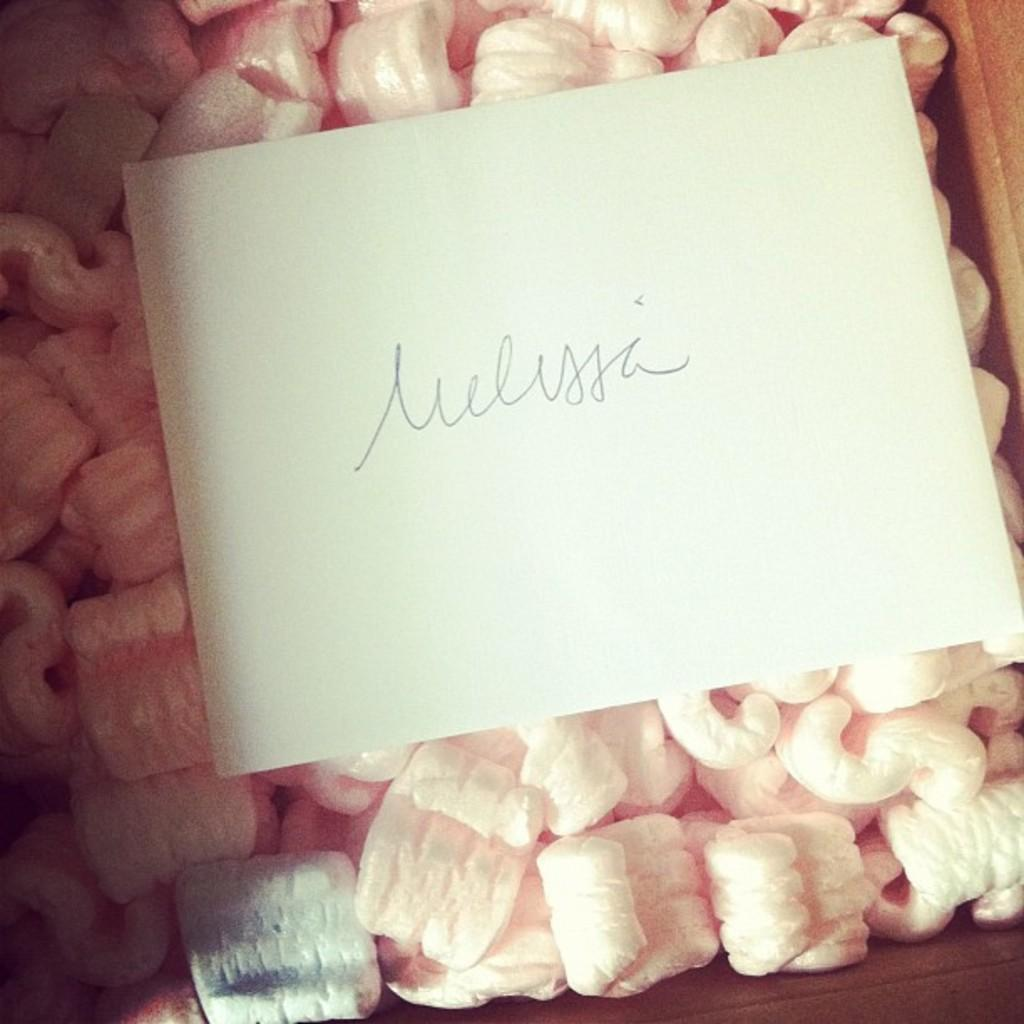What is present in the image? There is a paper in the image. What can be found on the paper? There is text on the paper. How is the text on the paper described? The text resembles marshmallows at the bottom. What type of silk is used to create the spoon in the image? There is no spoon or silk present in the image. 